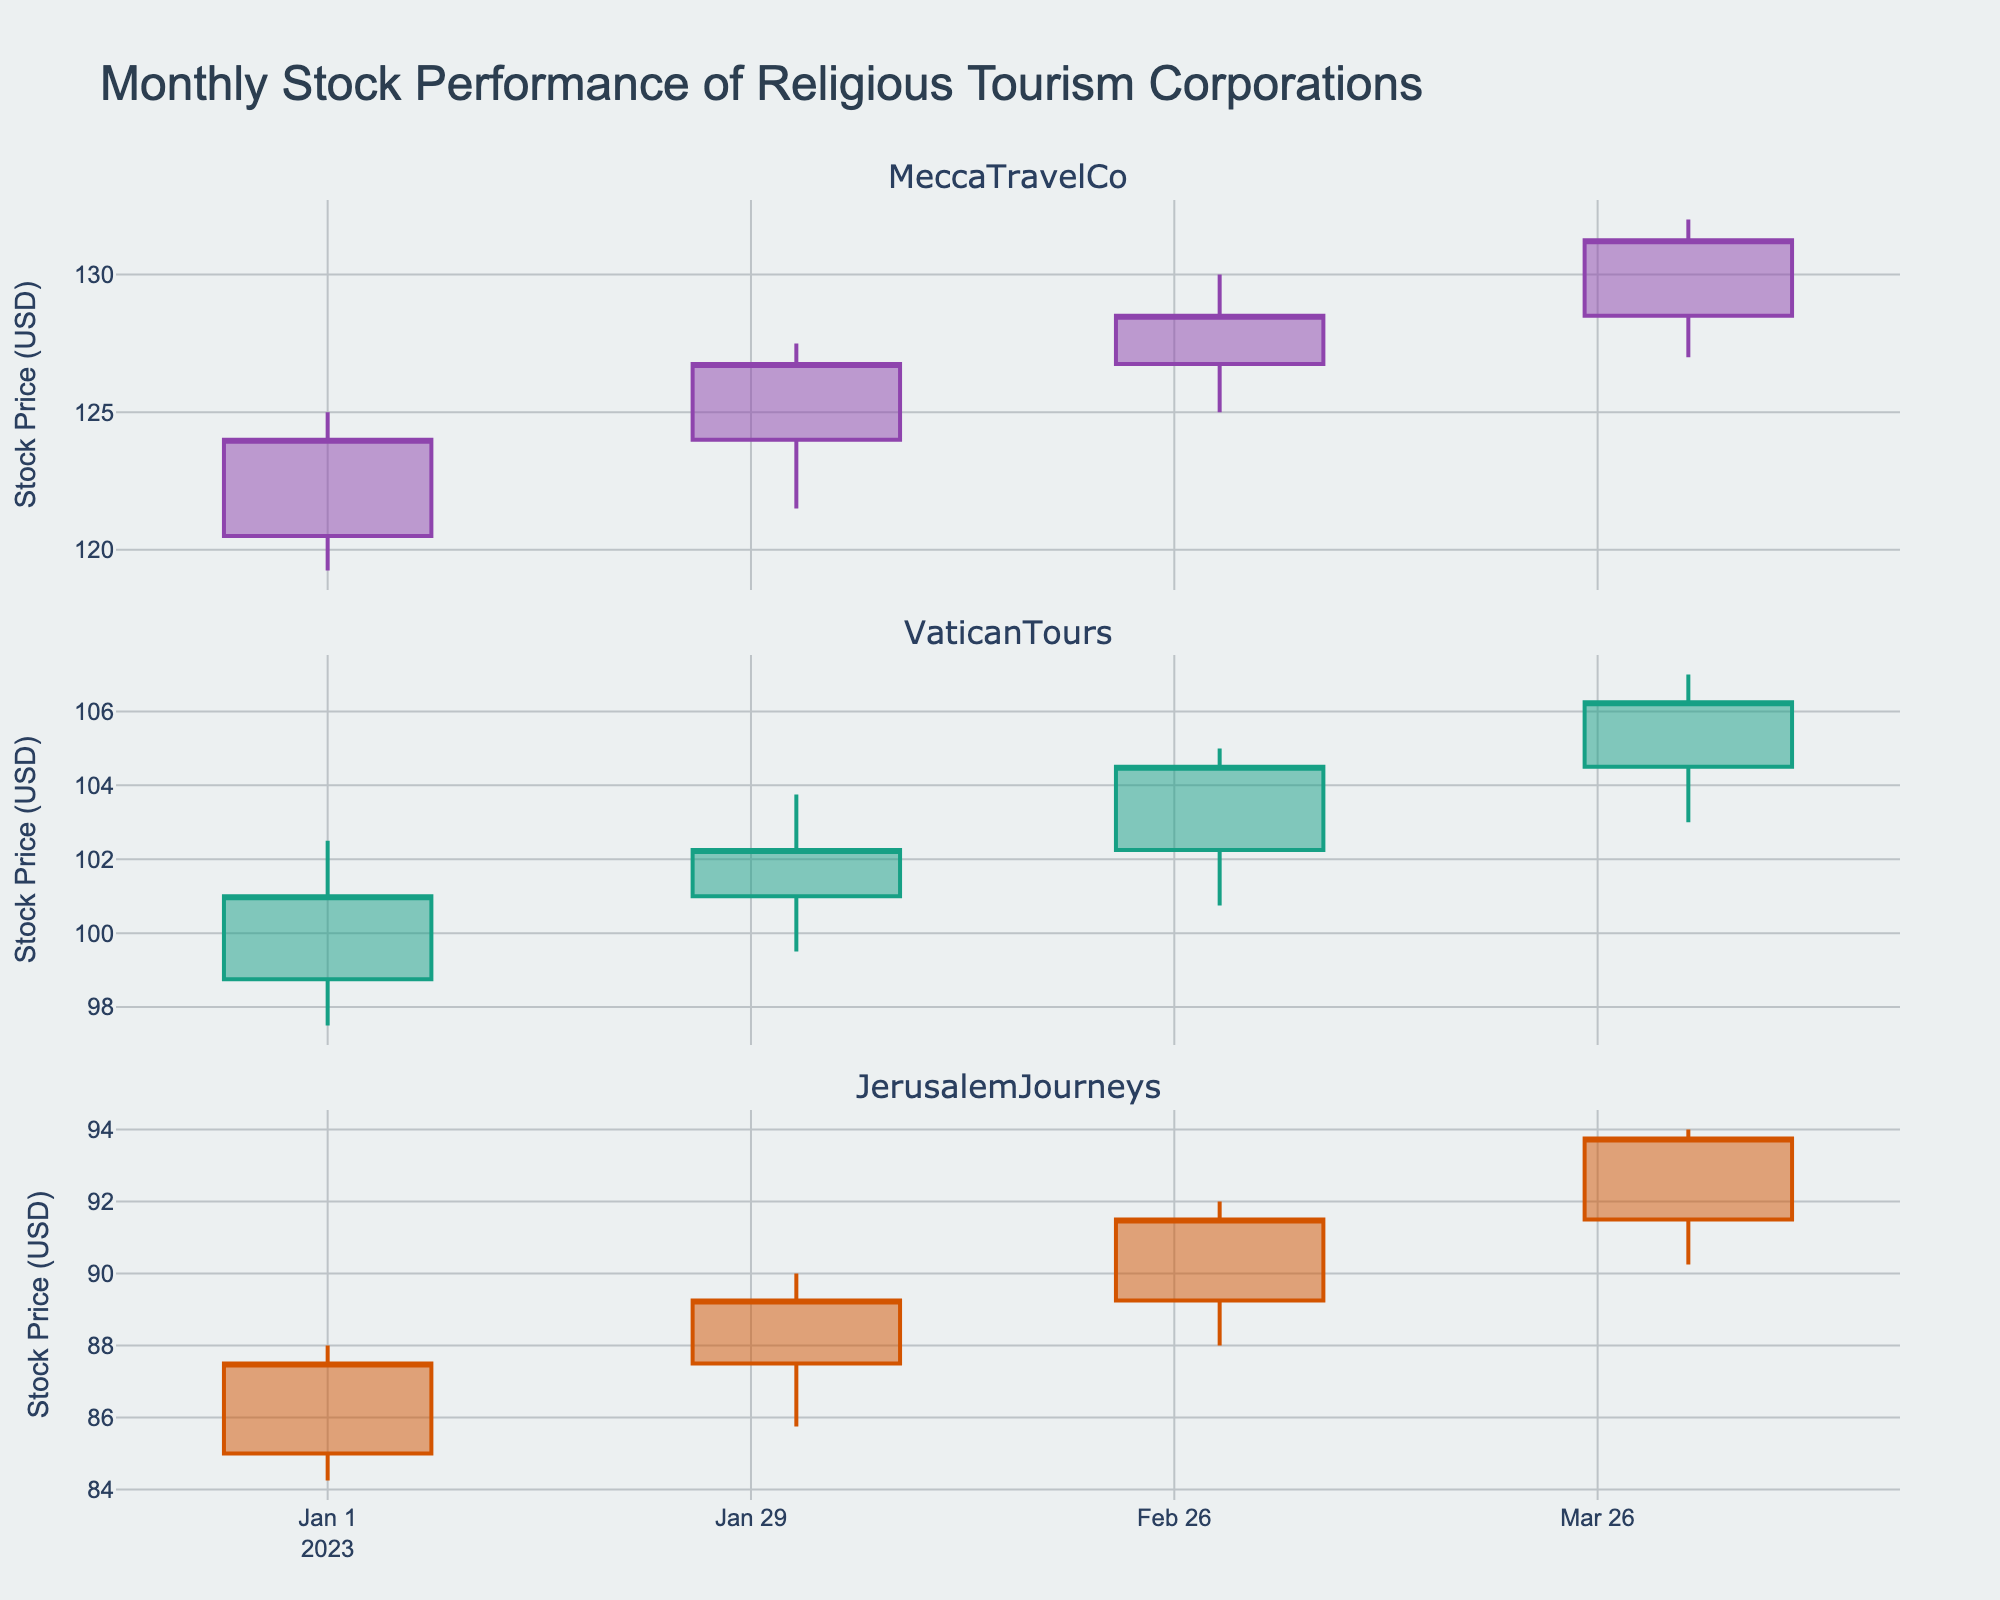What is the title of the figure? The title is usually prominently displayed at the top of the figure. In this case, it should clearly state the main subject or focus of the visual data.
Answer: Monthly Stock Performance of Religious Tourism Corporations How many companies' stock performances are displayed in the figure? Each subplot represents a different company. Count the number of subplot titles or the distinct colors used for each company's data.
Answer: Three Which company has the highest stock price in January 2023? Examine the candlestick plot for each company in January. Look for the candlestick with the highest "High" value.
Answer: MeccaTravelCo Did VaticanTours' closing stock price increase or decrease from January to February 2023? Look at two candlesticks for VaticanTours, observe the "Close" value in January and compare it to February.
Answer: Increase Which month shows the highest trading volume for JerusalemJourneys? Check each month's volume data displayed usually at the bottom of the candlestick or as annotations. Identify the month with the highest volume value.
Answer: April 2023 Compare the stock price trends of MeccaTravelCo and VaticanTours from January to April 2023. Which of the companies had more consistent growth? Look at the candlestick patterns for both companies from January to April. Consistent growth is indicated by a progressive increase in the "Close" values over the months.
Answer: MeccaTravelCo Identify the month when MeccaTravelCo experienced the largest price increase within the month. What was this increase? For MeccaTravelCo, calculate the difference between the month's "High" and "Low" prices. Identify the month with the maximum difference.
Answer: April 2023, $5.00 Which company had the least volatile stock price in March 2023? Compare the "High" and "Low" values for each company in March. The smaller the difference, the less the volatility.
Answer: VaticanTours How does the trading volume of VaticanTours change over the months? Observe the volume data for VaticanTours for each month. Note if it generally increases, decreases, or fluctuates.
Answer: Increases Between which two months did JerusalemJourneys experience the highest percentage increase in closing stock price? What was this percentage increase? Calculate the percentage increase in closing price between the consecutive months for JerusalemJourneys. (New Price - Old Price) / Old Price * 100. Compare the percentages to find the highest.
Answer: March to April, approximately 2.8% 